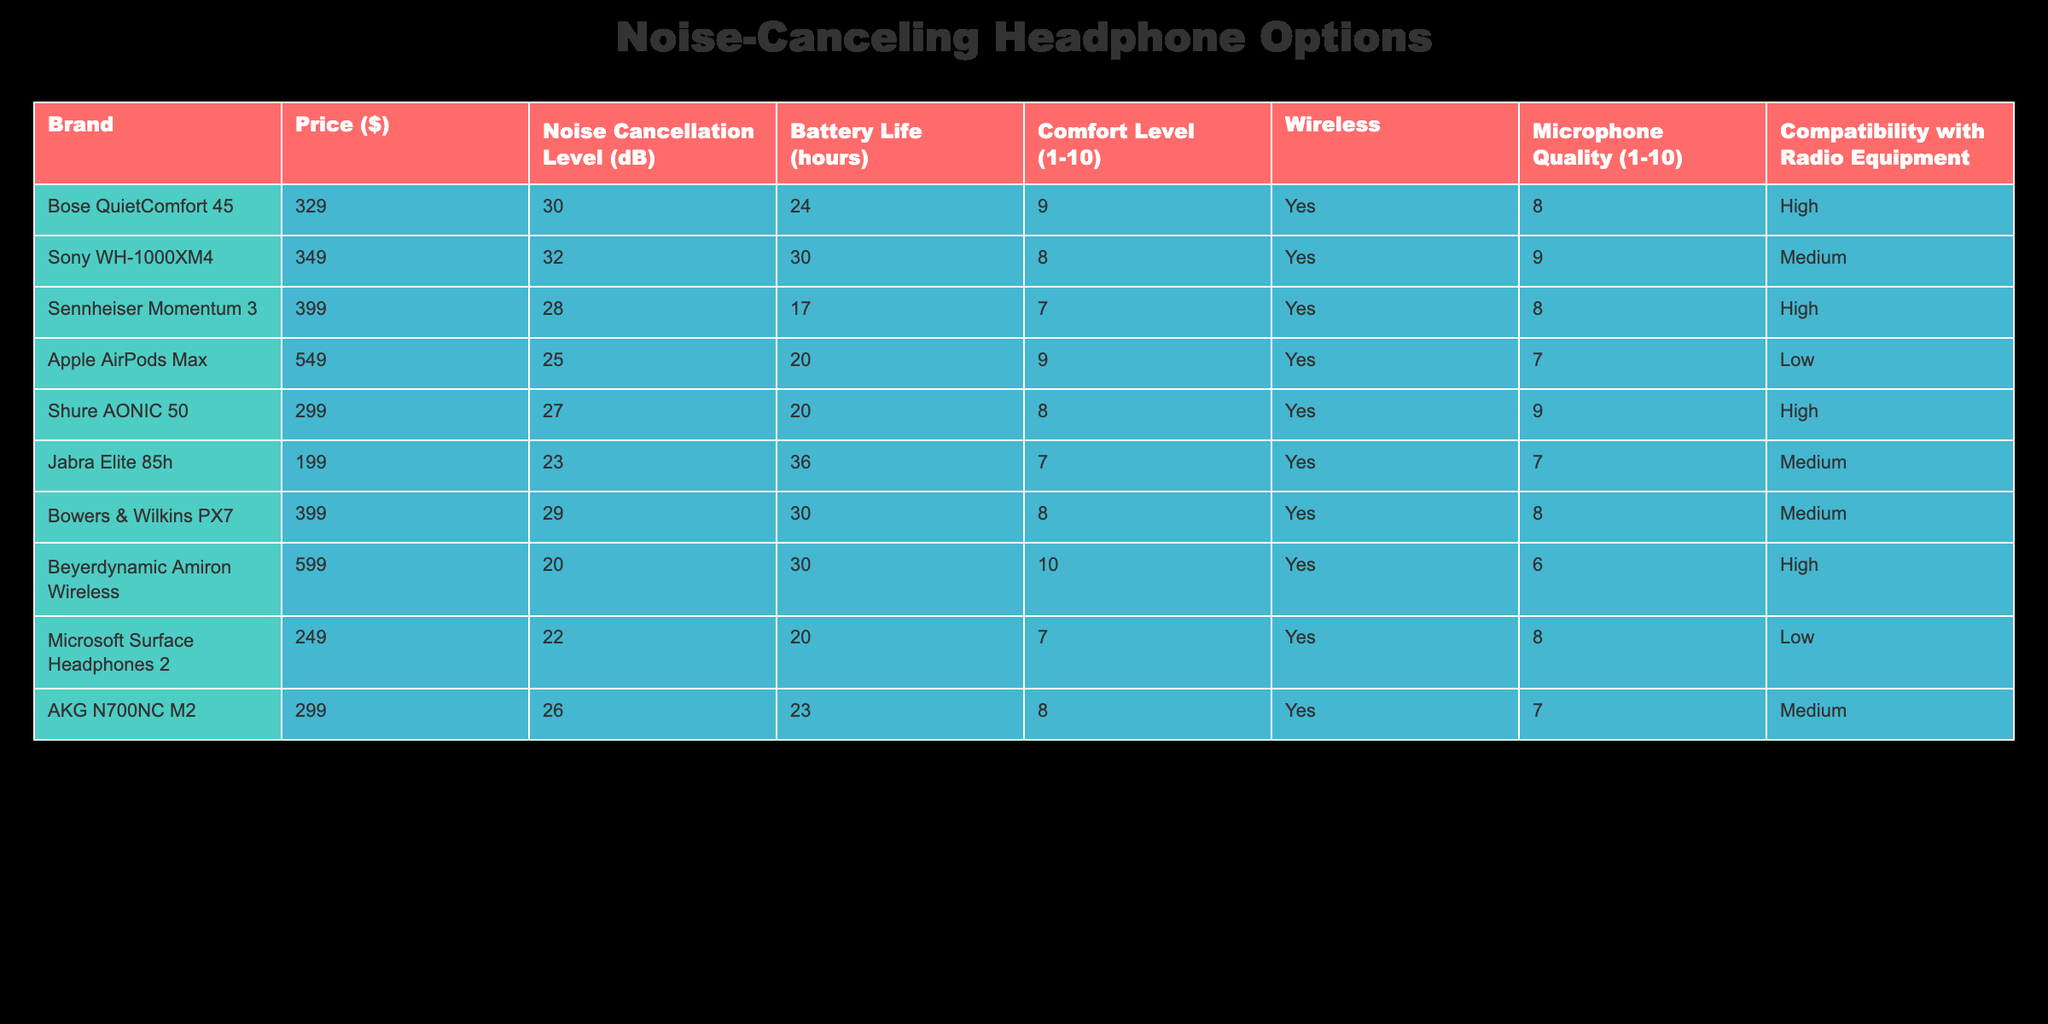What is the price of the Sony WH-1000XM4 headphones? The table lists the price in the “Price ($)” column for each brand. The Sony WH-1000XM4 is listed at $349.
Answer: 349 Which headphone has the highest noise cancellation level? In the “Noise Cancellation Level (dB)” column, I can see that the Sony WH-1000XM4 has the highest level at 32 dB.
Answer: 32 dB Is the Jabra Elite 85h compatible with radio equipment? The table has a “Compatibility with Radio Equipment” column that indicates compatibility status. The Jabra Elite 85h is marked as “Medium,” which suggests it is not fully compatible.
Answer: No What is the average comfort level of all headphones listed? To find the average, I will sum all values in the “Comfort Level (1-10)” column: (9 + 8 + 7 + 9 + 8 + 7 + 8 + 10 + 6 + 8) = 78. Then, I divide by the total number of headphones (10), so 78/10 = 7.8.
Answer: 7.8 Which headphones have a battery life longer than 25 hours? I need to check the “Battery Life (hours)” column to identify which entries exceed 25 hours. The Jabra Elite 85h (36 hours), Sony WH-1000XM4 (30 hours), and Bose QuietComfort 45 (24 hours) qualify. The Sony WH-1000XM4 and the Jabra Elite 85h have battery lives longer than 25 hours.
Answer: Sony WH-1000XM4, Jabra Elite 85h What percentage of headphones listed have a microphone quality rating of 8 or higher? First, count the number of headphones with a rating of 8 or more in the “Microphone Quality (1-10)” column. There are 5 headphones (Sony WH-1000XM4, Shure AONIC 50, Microsoft Surface Headphones 2, Bose QuietComfort 45, and AKG N700NC M2). There are a total of 10 headphones, so (5/10) * 100 = 50%.
Answer: 50% Which brand provides the most well-rounded options in terms of noise cancellation, comfort, and battery life? The “Noise Cancellation Level,” “Comfort Level,” and “Battery Life” columns must all be considered. The Sony WH-1000XM4 scores best in noise and battery but is slightly lower in comfort. The Bose QuietComfort 45 is a close contender with high comfort and decent noise levels. After analysis, both have strengths but the Sony WH-1000XM4 edges out on a balanced score across factors.
Answer: Sony WH-1000XM4 Does the Apple AirPods Max have a wireless feature? The “Wireless” column indicates whether each headphone is wireless. Since the Apple AirPods Max is marked “Yes”, it confirms this feature.
Answer: Yes 